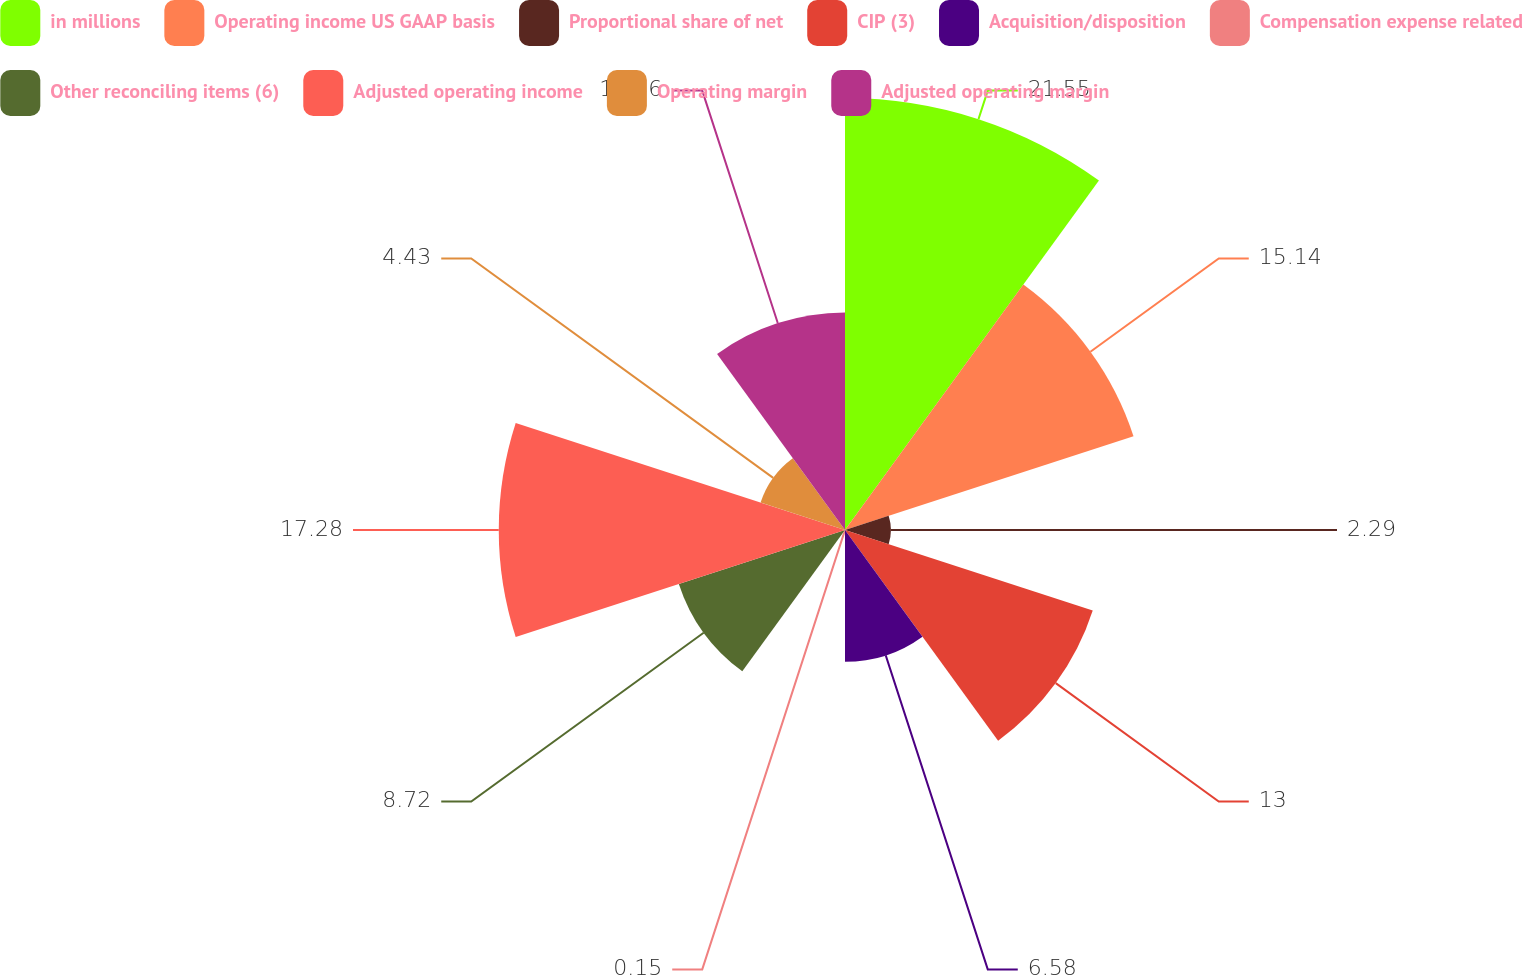<chart> <loc_0><loc_0><loc_500><loc_500><pie_chart><fcel>in millions<fcel>Operating income US GAAP basis<fcel>Proportional share of net<fcel>CIP (3)<fcel>Acquisition/disposition<fcel>Compensation expense related<fcel>Other reconciling items (6)<fcel>Adjusted operating income<fcel>Operating margin<fcel>Adjusted operating margin<nl><fcel>21.56%<fcel>15.14%<fcel>2.29%<fcel>13.0%<fcel>6.58%<fcel>0.15%<fcel>8.72%<fcel>17.28%<fcel>4.43%<fcel>10.86%<nl></chart> 